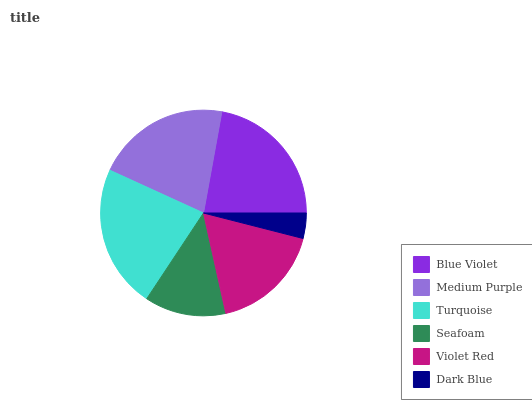Is Dark Blue the minimum?
Answer yes or no. Yes. Is Turquoise the maximum?
Answer yes or no. Yes. Is Medium Purple the minimum?
Answer yes or no. No. Is Medium Purple the maximum?
Answer yes or no. No. Is Blue Violet greater than Medium Purple?
Answer yes or no. Yes. Is Medium Purple less than Blue Violet?
Answer yes or no. Yes. Is Medium Purple greater than Blue Violet?
Answer yes or no. No. Is Blue Violet less than Medium Purple?
Answer yes or no. No. Is Medium Purple the high median?
Answer yes or no. Yes. Is Violet Red the low median?
Answer yes or no. Yes. Is Turquoise the high median?
Answer yes or no. No. Is Dark Blue the low median?
Answer yes or no. No. 